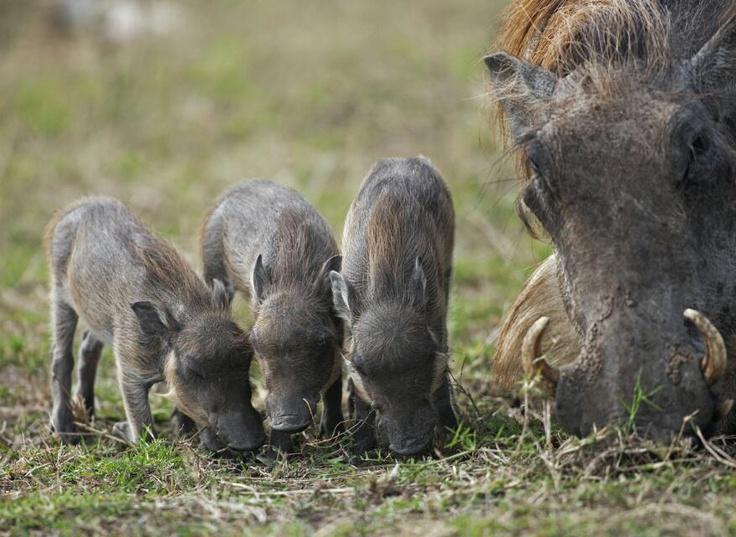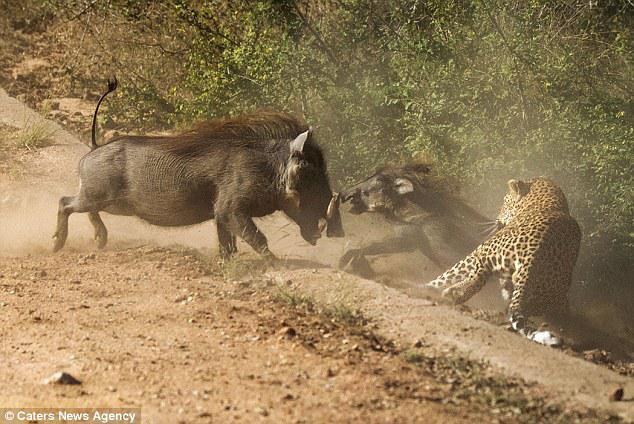The first image is the image on the left, the second image is the image on the right. Given the left and right images, does the statement "An image includes multiple piglets with an adult warthog standing in profile facing leftward." hold true? Answer yes or no. No. The first image is the image on the left, the second image is the image on the right. Considering the images on both sides, is "An image contains a cheetah attacking a wart hog." valid? Answer yes or no. Yes. 